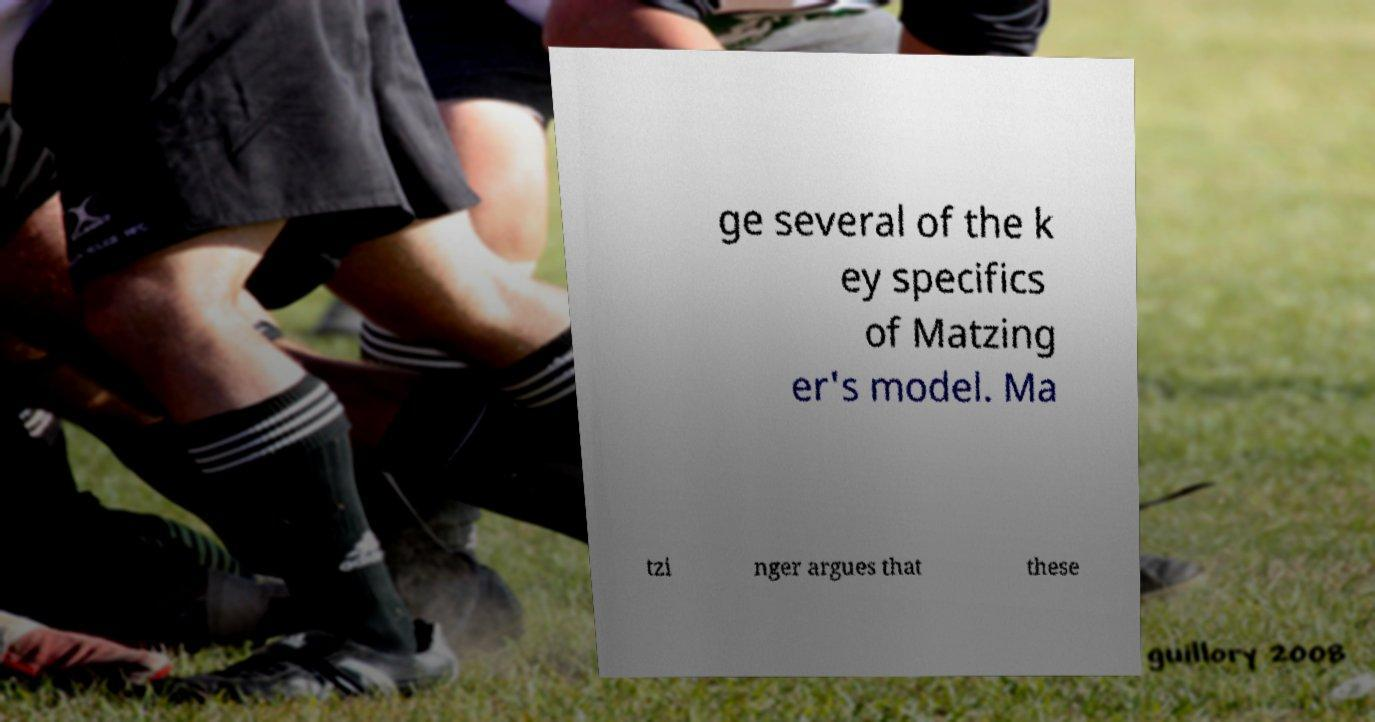Could you extract and type out the text from this image? ge several of the k ey specifics of Matzing er's model. Ma tzi nger argues that these 